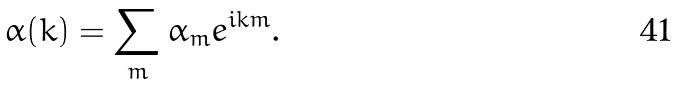<formula> <loc_0><loc_0><loc_500><loc_500>\alpha ( k ) = \sum _ { m } \alpha _ { m } e ^ { i k m } .</formula> 